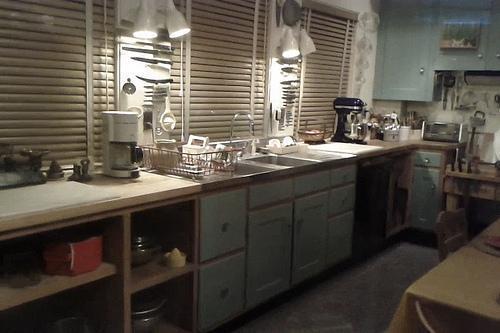How many chairs are there?
Give a very brief answer. 1. 